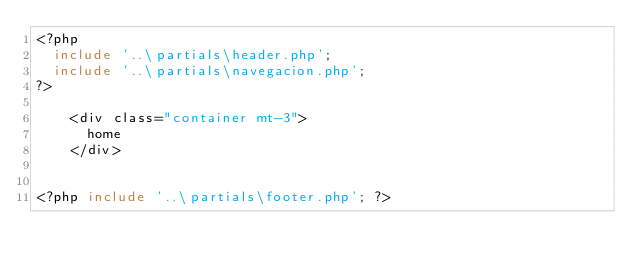Convert code to text. <code><loc_0><loc_0><loc_500><loc_500><_PHP_><?php
  include '..\partials\header.php';
  include '..\partials\navegacion.php';
?>

    <div class="container mt-3">
      home
    </div>


<?php include '..\partials\footer.php'; ?>
</code> 